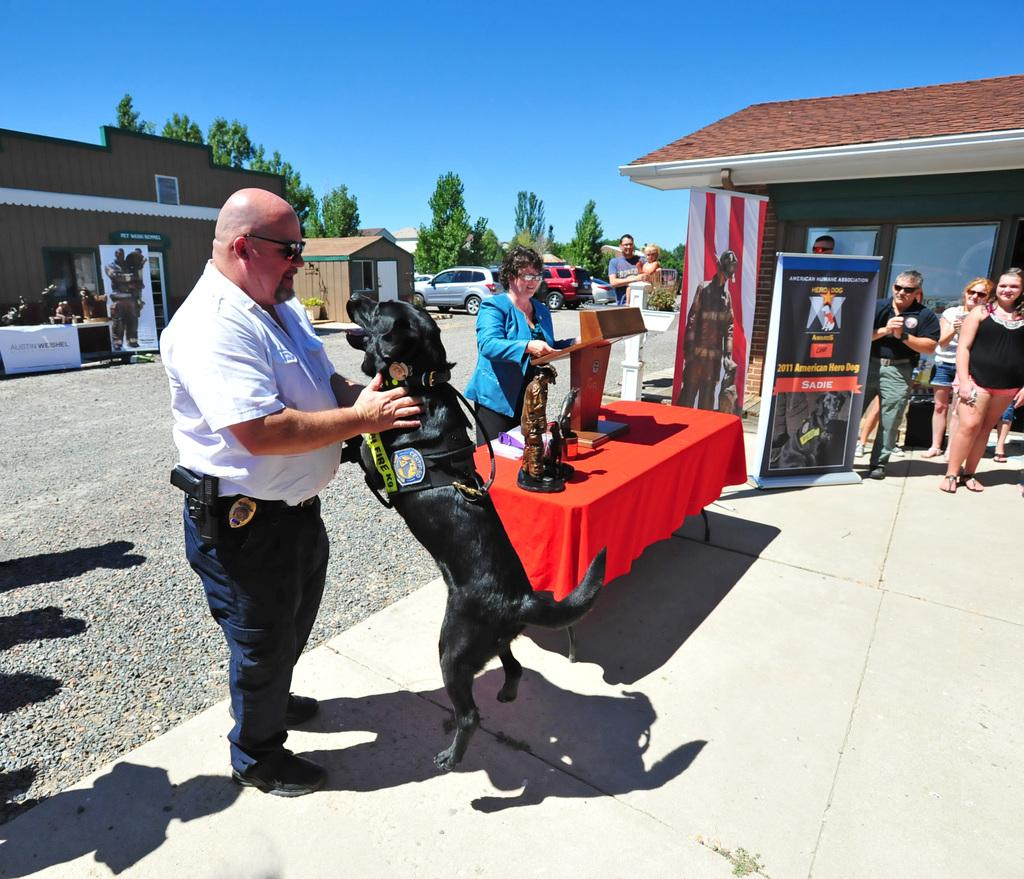How many people are in the image? There is a group of people in the image. Can you describe the person in the center of the group? The person in the center of the group is wearing a white shirt and holding a dog. What can be seen in the background of the image? There is a house, a tree, and a car in the background of the image. What type of owl can be seen sitting on the person's shoulder in the image? There is no owl present in the image; the person is holding a dog. How many brothers are visible in the image? The provided facts do not mention any brothers, so it cannot be determined from the image. 